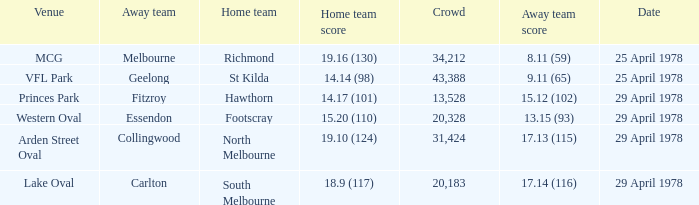What was the away team that played at Princes Park? Fitzroy. 